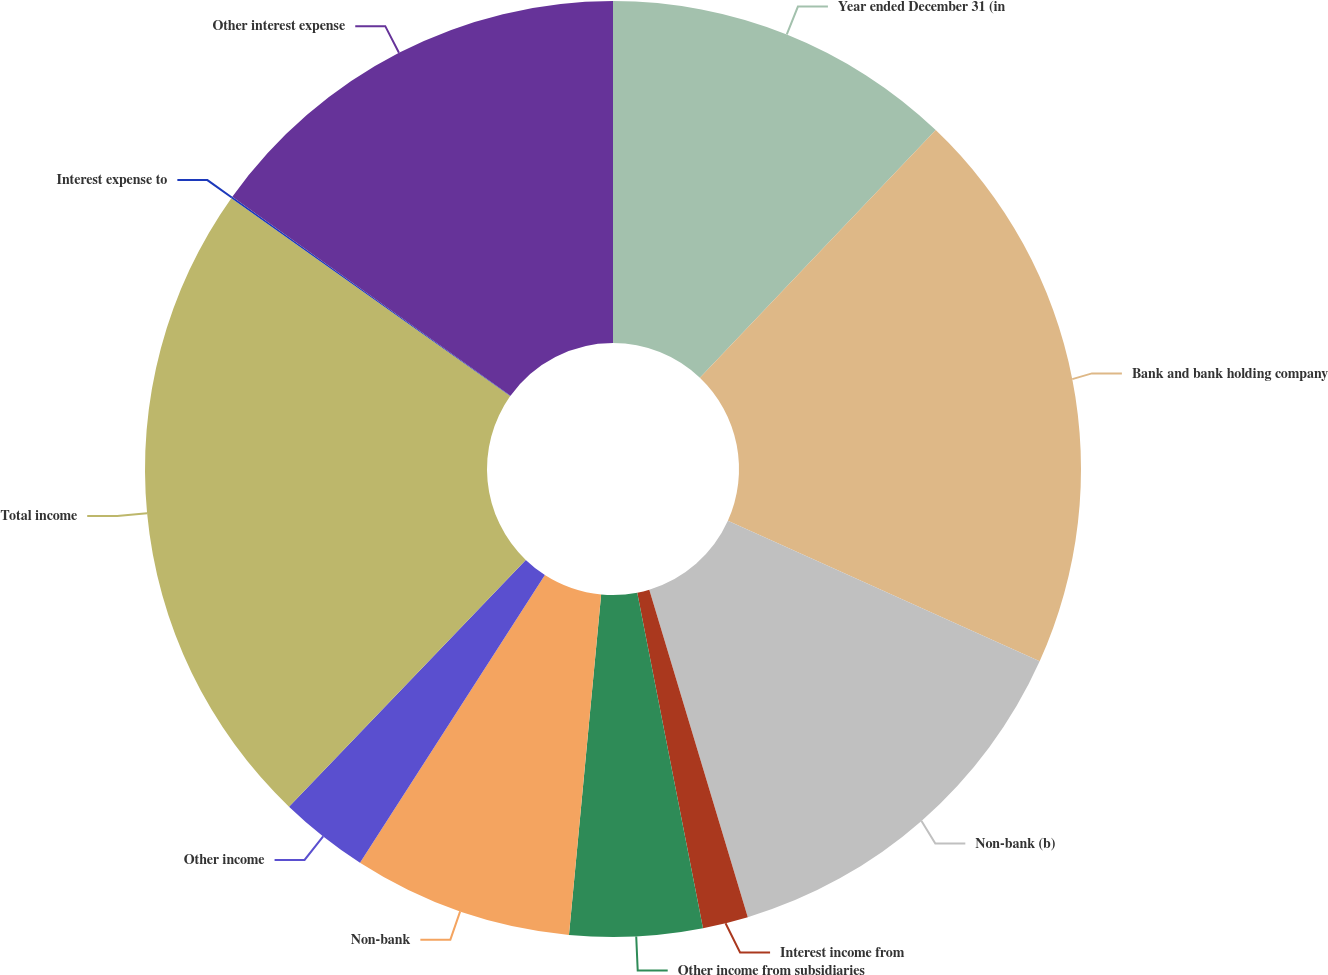Convert chart. <chart><loc_0><loc_0><loc_500><loc_500><pie_chart><fcel>Year ended December 31 (in<fcel>Bank and bank holding company<fcel>Non-bank (b)<fcel>Interest income from<fcel>Other income from subsidiaries<fcel>Non-bank<fcel>Other income<fcel>Total income<fcel>Interest expense to<fcel>Other interest expense<nl><fcel>12.11%<fcel>19.63%<fcel>13.61%<fcel>1.57%<fcel>4.58%<fcel>7.59%<fcel>3.08%<fcel>22.65%<fcel>0.06%<fcel>15.12%<nl></chart> 